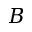Convert formula to latex. <formula><loc_0><loc_0><loc_500><loc_500>B</formula> 